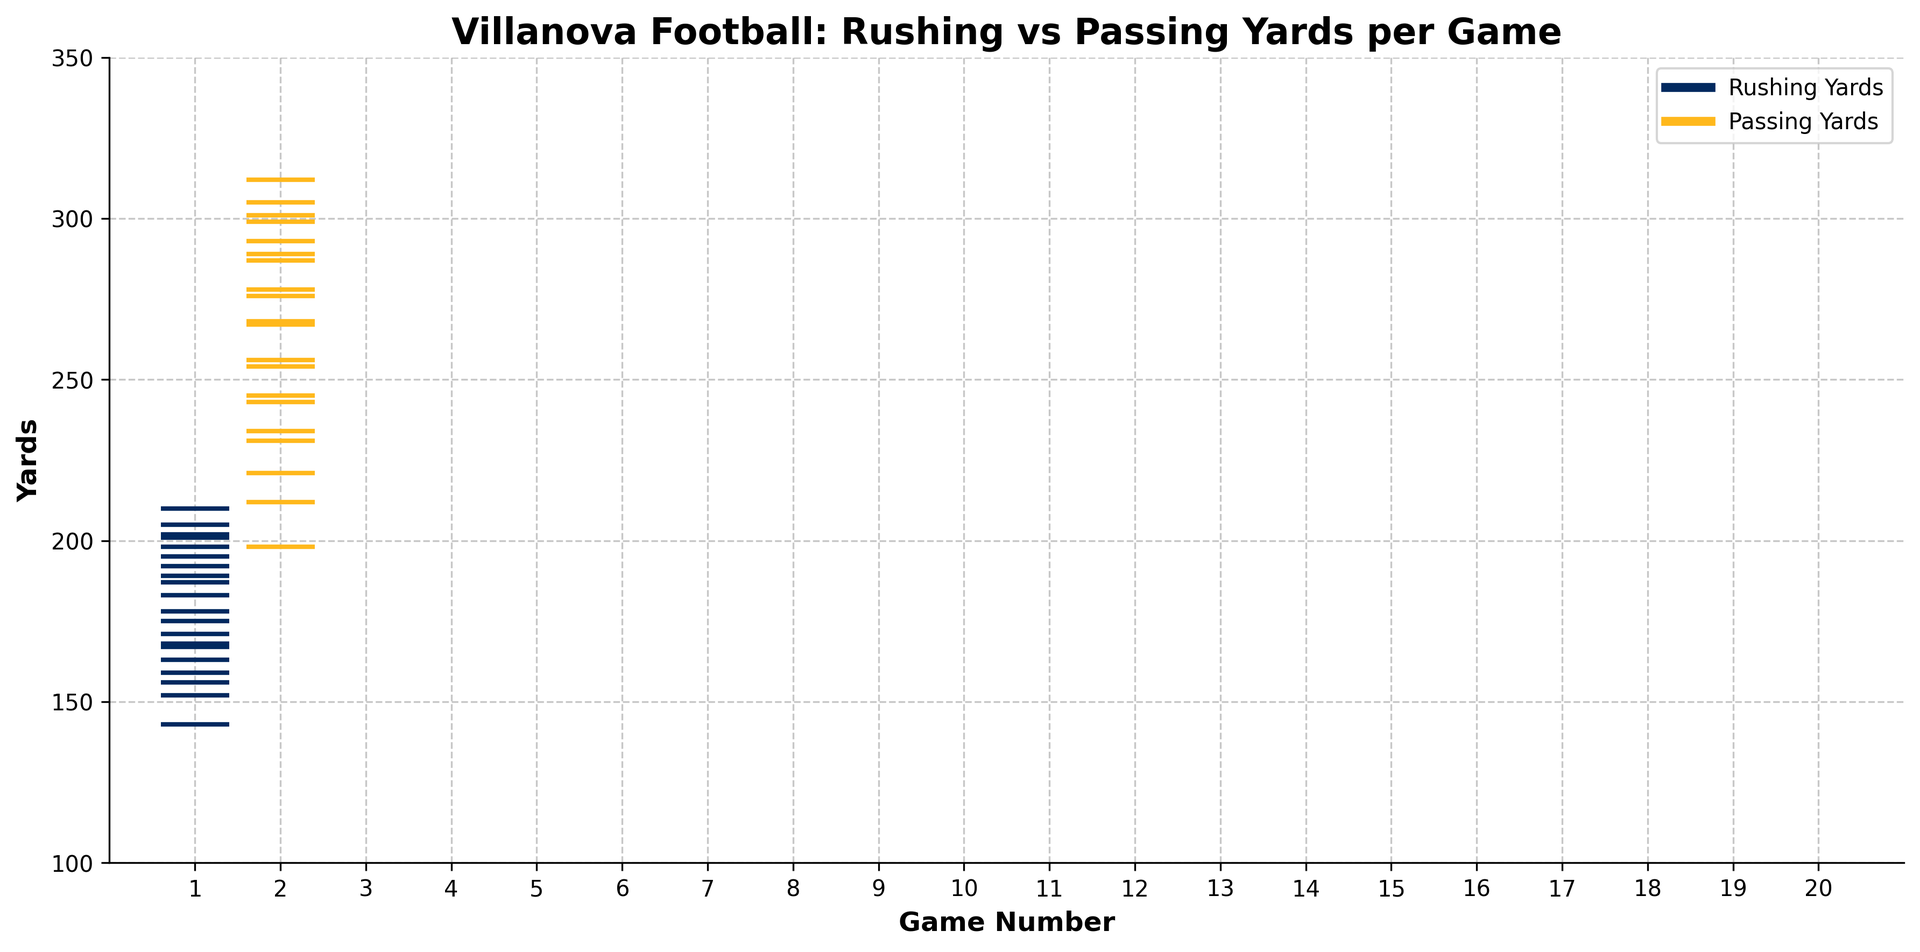What's the highest rushing yards achieved in any game? To find the highest rushing yards, look at the blue lines in the plot and identify the tallest one along the y-axis. The highest point reached by a blue line is around 210.
Answer: 210 Which game had the most passing yards? To determine which game had the most passing yards, locate the tallest golden line in the plot. This is around game 10, where the line reaches slightly above 300 yards.
Answer: Game 10 Did the team gain more rushing or passing yards on average per game? Calculate the average for both rushing and passing yards. For rushing, sum up the rushing yards and divide by the number of games (20). Do the same for passing yards. Compare the two averages. The average rushing yards are around 180.4 (sum=3608, games=20), and the average passing yards are around 265.3 (sum=5306, games=20).
Answer: Passing yards In which game did the team have the same number of rushing and passing yards? Look for any game where the positions of the blue and golden lines overlap exactly. From the plot, there is no game where the rushing and passing yards are the same.
Answer: None Which game saw a significant drop in rushing yards compared to the previous game? Observe the pattern of blue lines and identify the game where there's a noticeable decrease in height compared to the previous game. Between game 5 (143 yards) and game 6 (192 yards), there is a drop.
Answer: Game 5 What is the largest difference in yards gained between rushing and passing in any game? For each game, calculate the absolute difference between rushing and passing yards, then find the maximum difference. For example, in game 10, the difference between 152 rushing yards and 312 passing yards is 160. The maximum difference is about 160 yards.
Answer: 160 In which game did the team gain the least total yards? Total yards per game is the sum of rushing and passing yards. Identify the game with the lowest combined height of the blue and golden lines. The game with the least total yards is game 1 with 187 rushing and 245 passing, totaling 432 yards.
Answer: Game 1 How does the distribution of rushing yards compare to passing yards across the season? Visually compare the clustering of blue and golden lines. Rushing yards (blue) are generally more clustered lower on the y-axis, while passing yards (golden) are more dispersed higher in the plot.
Answer: Passing yards generally higher How many times did the team gain more than 200 rushing yards in a game? Count the number of blue lines that reach or exceed the 200-yard mark. From the plot, this occurs in games 3 (201), 8 (210), 14 (205), and 19 (202).
Answer: 4 